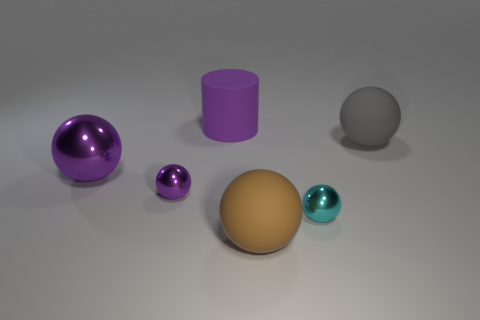Subtract all gray balls. How many balls are left? 4 Subtract all brown matte balls. How many balls are left? 4 Subtract 2 balls. How many balls are left? 3 Subtract all yellow spheres. Subtract all cyan cylinders. How many spheres are left? 5 Add 1 metallic objects. How many objects exist? 7 Subtract all spheres. How many objects are left? 1 Subtract all brown balls. Subtract all rubber balls. How many objects are left? 3 Add 6 brown rubber spheres. How many brown rubber spheres are left? 7 Add 1 tiny green objects. How many tiny green objects exist? 1 Subtract 0 blue cylinders. How many objects are left? 6 